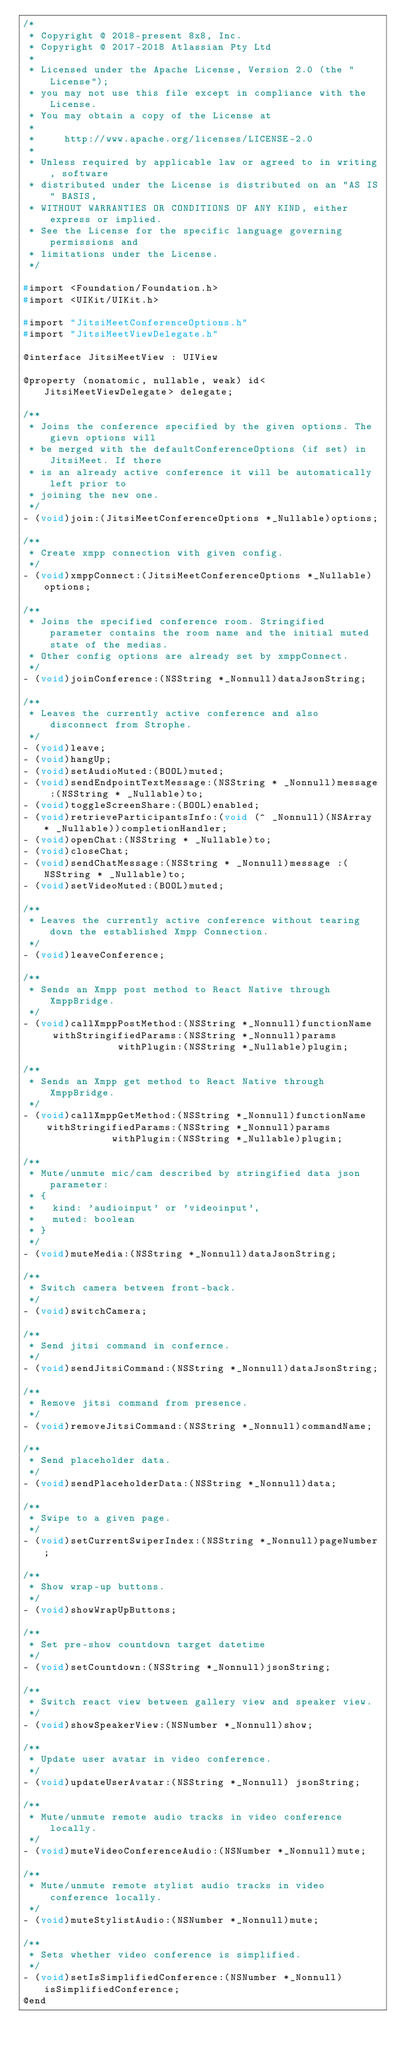<code> <loc_0><loc_0><loc_500><loc_500><_C_>/*
 * Copyright @ 2018-present 8x8, Inc.
 * Copyright @ 2017-2018 Atlassian Pty Ltd
 *
 * Licensed under the Apache License, Version 2.0 (the "License");
 * you may not use this file except in compliance with the License.
 * You may obtain a copy of the License at
 *
 *     http://www.apache.org/licenses/LICENSE-2.0
 *
 * Unless required by applicable law or agreed to in writing, software
 * distributed under the License is distributed on an "AS IS" BASIS,
 * WITHOUT WARRANTIES OR CONDITIONS OF ANY KIND, either express or implied.
 * See the License for the specific language governing permissions and
 * limitations under the License.
 */

#import <Foundation/Foundation.h>
#import <UIKit/UIKit.h>

#import "JitsiMeetConferenceOptions.h"
#import "JitsiMeetViewDelegate.h"

@interface JitsiMeetView : UIView

@property (nonatomic, nullable, weak) id<JitsiMeetViewDelegate> delegate;

/**
 * Joins the conference specified by the given options. The gievn options will
 * be merged with the defaultConferenceOptions (if set) in JitsiMeet. If there
 * is an already active conference it will be automatically left prior to
 * joining the new one.
 */
- (void)join:(JitsiMeetConferenceOptions *_Nullable)options;

/**
 * Create xmpp connection with given config.
 */
- (void)xmppConnect:(JitsiMeetConferenceOptions *_Nullable)options;

/**
 * Joins the specified conference room. Stringified parameter contains the room name and the initial muted state of the medias.
 * Other config options are already set by xmppConnect.
 */
- (void)joinConference:(NSString *_Nonnull)dataJsonString;

/**
 * Leaves the currently active conference and also disconnect from Strophe.
 */
- (void)leave;
- (void)hangUp;
- (void)setAudioMuted:(BOOL)muted;
- (void)sendEndpointTextMessage:(NSString * _Nonnull)message :(NSString * _Nullable)to;
- (void)toggleScreenShare:(BOOL)enabled;
- (void)retrieveParticipantsInfo:(void (^ _Nonnull)(NSArray * _Nullable))completionHandler;
- (void)openChat:(NSString * _Nullable)to;
- (void)closeChat;
- (void)sendChatMessage:(NSString * _Nonnull)message :(NSString * _Nullable)to;
- (void)setVideoMuted:(BOOL)muted;

/**
 * Leaves the currently active conference without tearing down the established Xmpp Connection.
 */
- (void)leaveConference;

/**
 * Sends an Xmpp post method to React Native through XmppBridge.
 */
- (void)callXmppPostMethod:(NSString *_Nonnull)functionName
     withStringifiedParams:(NSString *_Nonnull)params
                withPlugin:(NSString *_Nullable)plugin;

/**
 * Sends an Xmpp get method to React Native through XmppBridge.
 */
- (void)callXmppGetMethod:(NSString *_Nonnull)functionName
    withStringifiedParams:(NSString *_Nonnull)params
               withPlugin:(NSString *_Nullable)plugin;

/**
 * Mute/unmute mic/cam described by stringified data json parameter:
 * {
 *   kind: 'audioinput' or 'videoinput',
 *   muted: boolean
 * }
 */
- (void)muteMedia:(NSString *_Nonnull)dataJsonString;

/**
 * Switch camera between front-back.
 */
- (void)switchCamera;

/**
 * Send jitsi command in confernce.
 */
- (void)sendJitsiCommand:(NSString *_Nonnull)dataJsonString;

/**
 * Remove jitsi command from presence.
 */
- (void)removeJitsiCommand:(NSString *_Nonnull)commandName;

/**
 * Send placeholder data.
 */
- (void)sendPlaceholderData:(NSString *_Nonnull)data;

/**
 * Swipe to a given page.
 */
- (void)setCurrentSwiperIndex:(NSString *_Nonnull)pageNumber;

/**
 * Show wrap-up buttons.
 */
- (void)showWrapUpButtons;

/**
 * Set pre-show countdown target datetime
 */
- (void)setCountdown:(NSString *_Nonnull)jsonString;

/**
 * Switch react view between gallery view and speaker view.
 */
- (void)showSpeakerView:(NSNumber *_Nonnull)show;

/**
 * Update user avatar in video conference.
 */
- (void)updateUserAvatar:(NSString *_Nonnull) jsonString;

/**
 * Mute/unmute remote audio tracks in video conference locally.
 */
- (void)muteVideoConferenceAudio:(NSNumber *_Nonnull)mute;

/**
 * Mute/unmute remote stylist audio tracks in video conference locally.
 */
- (void)muteStylistAudio:(NSNumber *_Nonnull)mute;

/**
 * Sets whether video conference is simplified.
 */
- (void)setIsSimplifiedConference:(NSNumber *_Nonnull)isSimplifiedConference;
@end
</code> 